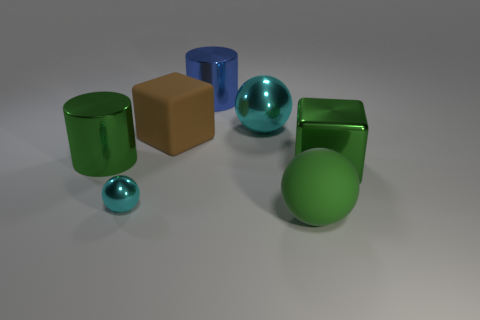Subtract all green balls. How many balls are left? 2 Subtract 1 blocks. How many blocks are left? 1 Add 1 large yellow metallic spheres. How many objects exist? 8 Subtract all yellow cylinders. How many brown blocks are left? 1 Subtract all small metallic things. Subtract all brown rubber blocks. How many objects are left? 5 Add 1 brown rubber things. How many brown rubber things are left? 2 Add 7 big green objects. How many big green objects exist? 10 Subtract all cyan balls. How many balls are left? 1 Subtract 0 yellow spheres. How many objects are left? 7 Subtract all cylinders. How many objects are left? 5 